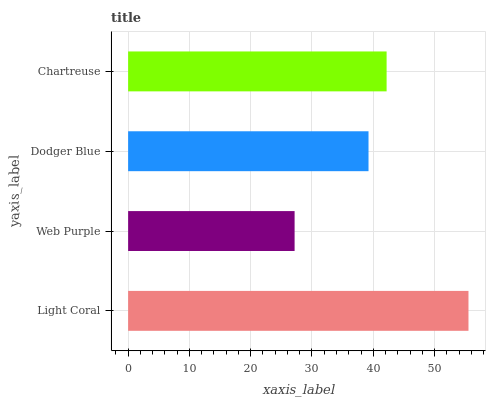Is Web Purple the minimum?
Answer yes or no. Yes. Is Light Coral the maximum?
Answer yes or no. Yes. Is Dodger Blue the minimum?
Answer yes or no. No. Is Dodger Blue the maximum?
Answer yes or no. No. Is Dodger Blue greater than Web Purple?
Answer yes or no. Yes. Is Web Purple less than Dodger Blue?
Answer yes or no. Yes. Is Web Purple greater than Dodger Blue?
Answer yes or no. No. Is Dodger Blue less than Web Purple?
Answer yes or no. No. Is Chartreuse the high median?
Answer yes or no. Yes. Is Dodger Blue the low median?
Answer yes or no. Yes. Is Web Purple the high median?
Answer yes or no. No. Is Chartreuse the low median?
Answer yes or no. No. 